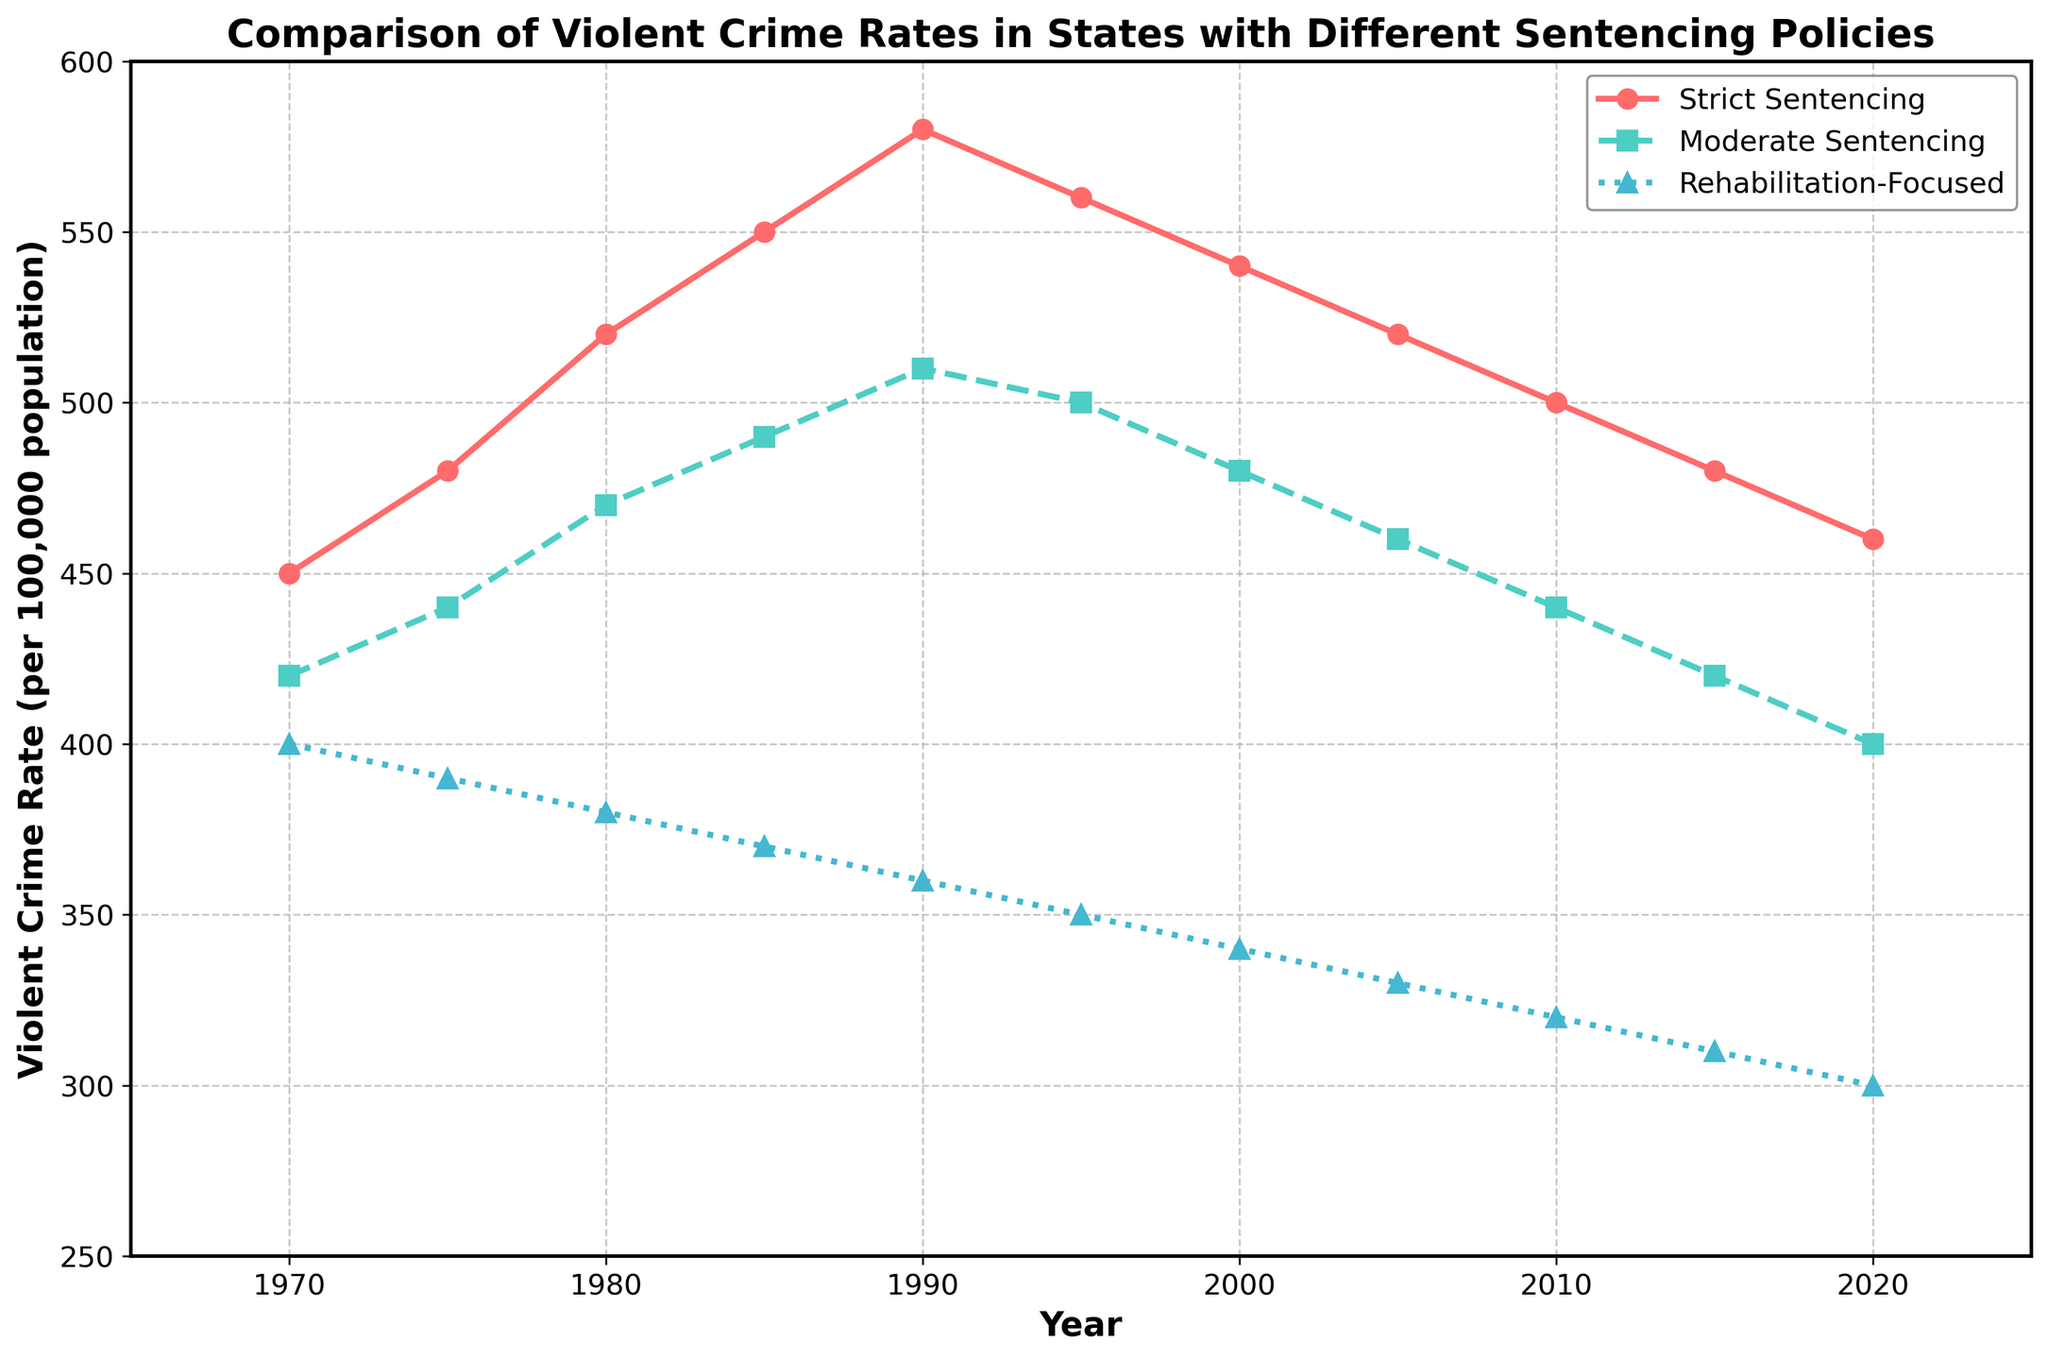What is the trend in violent crime rates in Strict Sentencing States from 1970 to 2020? By observing the line representing Strict Sentencing States (red line) from 1970 to 2020, we see that violent crime rates increased from 450 in 1970 to a peak of 580 in 1990 and then gradually decreased to 460 by 2020.
Answer: Increase to peak in 1990 then decrease Which states had the highest violent crime rate in 1990? In 1990, the violent crime rates for different sentencing policies were: Strict Sentencing States = 580, Moderate Sentencing States = 510, Rehabilitation-Focused States = 360. Therefore, Strict Sentencing States had the highest violent crime rate.
Answer: Strict Sentencing States By how much did the violent crime rate in Rehabilitation-Focused States decrease from 1970 to 2020? The violent crime rate in Rehabilitation-Focused States was 400 in 1970 and decreased to 300 in 2020. The difference is 400 - 300 = 100.
Answer: 100 Between which years did Moderate Sentencing States see the largest decrease in violent crime rates? From the data points, Moderate Sentencing States saw a decrease from 500 in 1995 to 480 in 2000, and then a continuous decline to 400 in 2020. The most significant drop during this period (20 units) occurred between 1995 and 2000.
Answer: 1995 to 2000 What is the overall trend for Rehabilitation-Focused States from 1970 to 2020? Observing the blue line of Rehabilitation-Focused States, we see that the violent crime rate consistently decreased over the years from 400 in 1970 to 300 in 2020 without any increase.
Answer: Consistently decreased Compare the crime rates between Strict Sentencing and Rehabilitation-Focused States in 2000. Which had a lower rate and by how much? The violent crime rate in 2000 for Strict Sentencing States was 540, while for Rehabilitation-Focused States, it was 340. The difference is 540 - 340 = 200, with Rehabilitation-Focused States being lower.
Answer: Rehabilitation-Focused by 200 What is the average violent crime rate for Moderate Sentencing States over the entire period? Sum the values for Moderate Sentencing States (420 + 440 + 470 + 490 + 510 + 500 + 480 + 460 + 440 + 420 + 400 = 5430) and divide by the number of years (11). The average is 5430 / 11 ≈ 493.64.
Answer: ≈ 493.64 In what year did the violent crime rate in Strict Sentencing States start to decrease after its highest point? The highest point for Strict Sentencing States was 580 in 1990, and it started to decrease from 1990 to 1995 when the rate dropped to 560.
Answer: 1990 In 2020, how does the crime rate in Moderate Sentencing States compare to that in Rehabilitation-Focused States? In 2020, the crime rate for Moderate Sentencing States was 400, and for Rehabilitation-Focused States, it was 300. Therefore, Moderate Sentencing States had a higher crime rate.
Answer: Moderate Sentencing States higher What is the difference in violent crime rate between Strict Sentencing States and the average of the other two categories in 1980? Strict Sentencing States had a violent crime rate of 520 in 1980. The average of the other two categories (Moderate: 470, Rehabilitation-Focused: 380) is (470 + 380) / 2 = 425. The difference is 520 - 425 = 95.
Answer: 95 